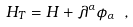<formula> <loc_0><loc_0><loc_500><loc_500>H _ { T } = H + \lambda ^ { \alpha } \phi _ { \alpha } \ ,</formula> 